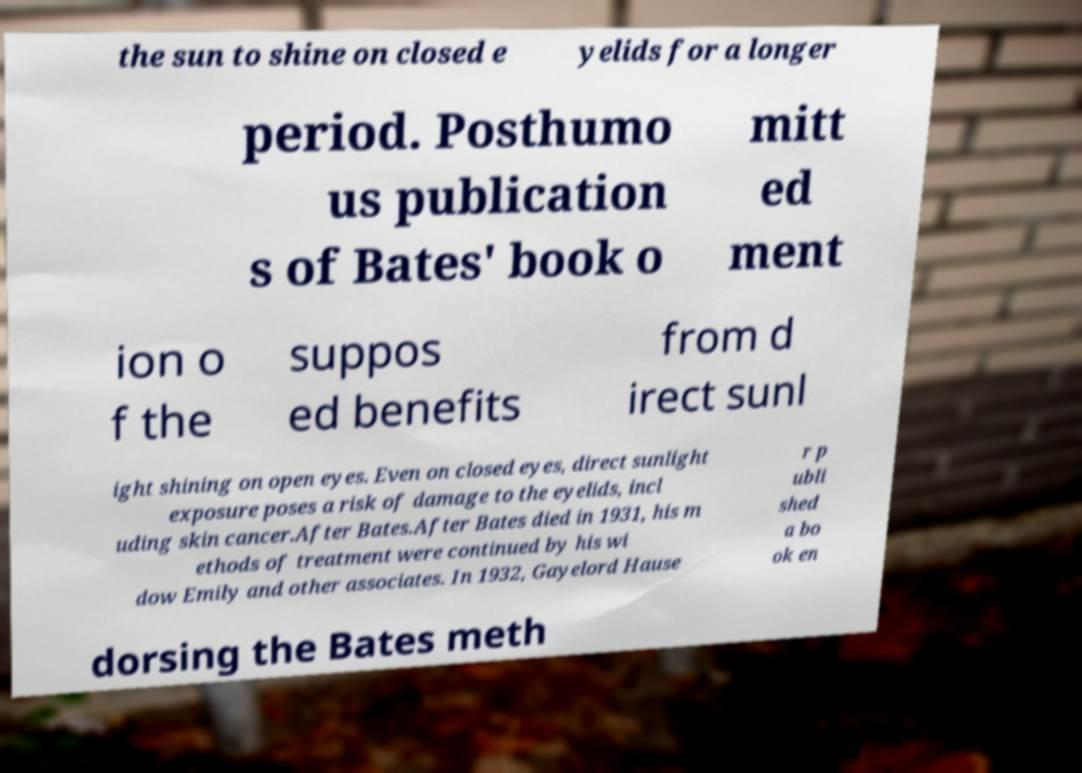Can you read and provide the text displayed in the image?This photo seems to have some interesting text. Can you extract and type it out for me? the sun to shine on closed e yelids for a longer period. Posthumo us publication s of Bates' book o mitt ed ment ion o f the suppos ed benefits from d irect sunl ight shining on open eyes. Even on closed eyes, direct sunlight exposure poses a risk of damage to the eyelids, incl uding skin cancer.After Bates.After Bates died in 1931, his m ethods of treatment were continued by his wi dow Emily and other associates. In 1932, Gayelord Hause r p ubli shed a bo ok en dorsing the Bates meth 